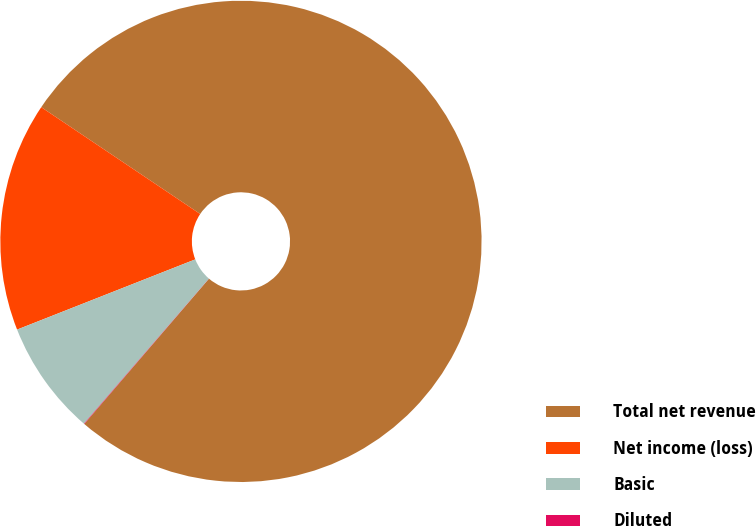Convert chart. <chart><loc_0><loc_0><loc_500><loc_500><pie_chart><fcel>Total net revenue<fcel>Net income (loss)<fcel>Basic<fcel>Diluted<nl><fcel>76.86%<fcel>15.39%<fcel>7.71%<fcel>0.03%<nl></chart> 